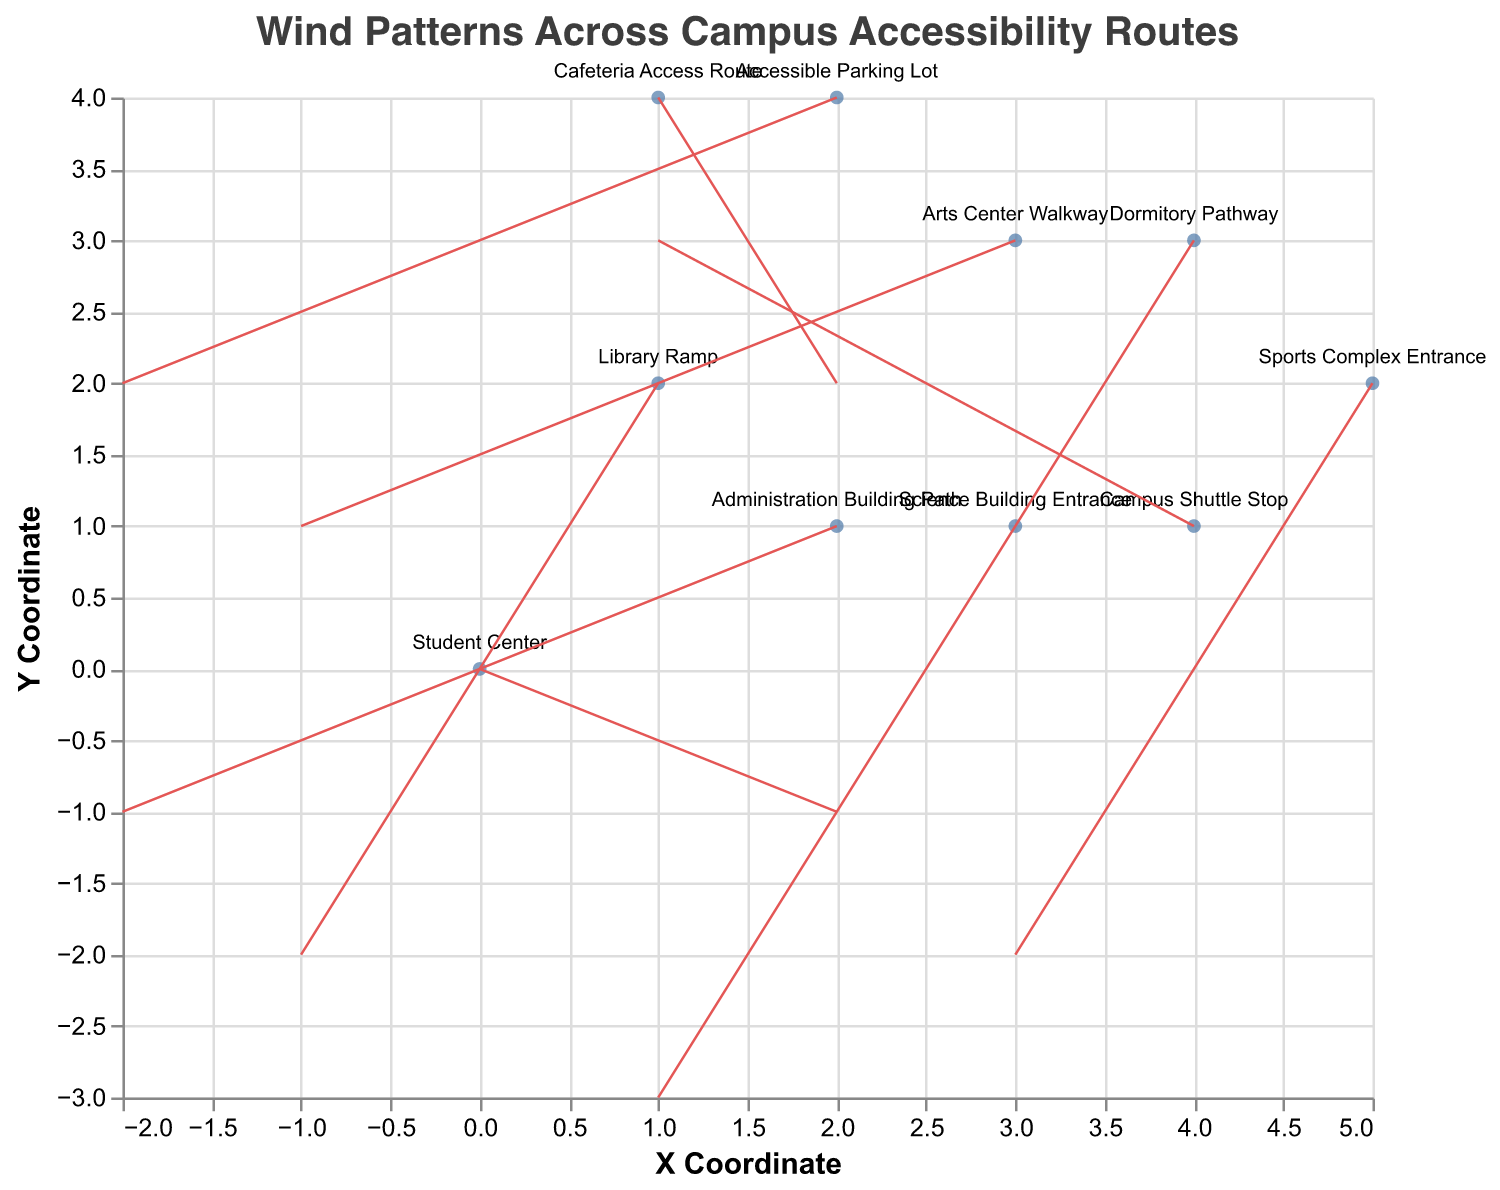What is the title of the plot? The title is displayed at the top of the plot, indicating the overall subject or purpose of the visualization.
Answer: Wind Patterns Across Campus Accessibility Routes What do the red lines in the plot represent? The red lines are "rules" that indicate the direction and intensity (u, v components) of the wind at various locations on the campus.
Answer: Wind direction and intensity What location experiences the strongest wind vector based on the length of the arrow? The longest arrow represents the strongest wind vector. By observing the plot, it can be seen that the arrow at the "Science Building Entrance" is the longest.
Answer: Science Building Entrance Which direction does the wind blow at the Campus Shuttle Stop? By looking at the arrow stemming from the "Campus Shuttle Stop," we observe that it extends upward (positive y direction) and slightly to the right (positive x direction).
Answer: Upward and to the right Which location has a wind vector pointing directly leftward? A wind vector pointing directly leftward has a negative u value and a v value of zero, which we see coming from the "Administration Building Path."
Answer: Administration Building Path How many locations were analyzed in the plot? The number of points marked on the plot represents the number of locations analyzed. By counting these, we see there are ten locations.
Answer: Ten What is the average u-component of the wind vectors across all locations? To find the average u-component, we add up all u values (2, -1, 3, -2, 1, 2, -1, 3, -2, 1) then divide by the number of locations (10). Summing these values is 6, and 6/10 = 0.6.
Answer: 0.6 Which two locations have wind vectors of the same length but opposite directions? Wind vectors with the same length and opposite directions will have the same magnitude but reversed signs. Observing the arrows, the "Student Center" (2, -1) and "Dormitory Pathway" (1, -3) have lengths of √5 and √10 respectively, and "Arts Center Walkway" (-1, 1) and "Library Ramp" (-1, -2) have magnitudes of √2 and √5, none match precisely. Therefore, rechecking, precise matches are not found.
Answer: None What is the direction and magnitude of the wind at the "Cafeteria Access Route"? The direction is determined by the vector components (u=2, v=2). The magnitude is calculated as the square root of (u² + v²), hence √(2² + 2²) = √8 ≈ 2.83.
Answer: Direction: Diagonal (positive x and y), Magnitude: 2.83 Does any location have a wind vector pointing directly downward? If so, which one? A wind vector pointing directly downward has a positive v value as y decreases downward in common graphical representations. From our plot, none solely points in the downward direction.
Answer: No 